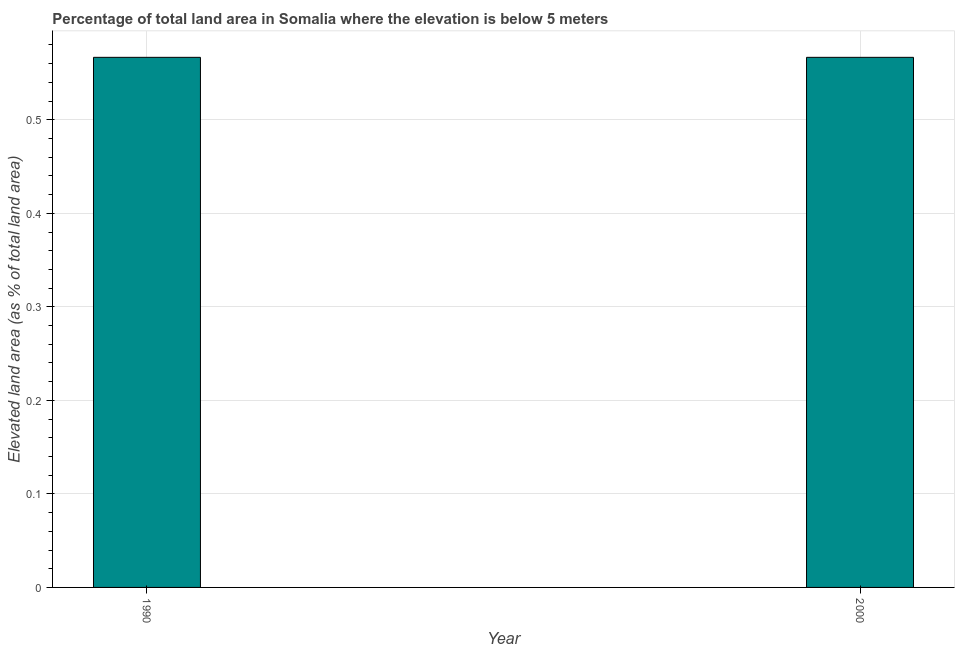Does the graph contain any zero values?
Make the answer very short. No. Does the graph contain grids?
Your answer should be very brief. Yes. What is the title of the graph?
Your answer should be compact. Percentage of total land area in Somalia where the elevation is below 5 meters. What is the label or title of the Y-axis?
Your response must be concise. Elevated land area (as % of total land area). What is the total elevated land area in 1990?
Your answer should be very brief. 0.57. Across all years, what is the maximum total elevated land area?
Ensure brevity in your answer.  0.57. Across all years, what is the minimum total elevated land area?
Keep it short and to the point. 0.57. In which year was the total elevated land area maximum?
Your answer should be compact. 1990. What is the sum of the total elevated land area?
Provide a short and direct response. 1.13. What is the difference between the total elevated land area in 1990 and 2000?
Give a very brief answer. 0. What is the average total elevated land area per year?
Provide a short and direct response. 0.57. What is the median total elevated land area?
Offer a very short reply. 0.57. Do a majority of the years between 1990 and 2000 (inclusive) have total elevated land area greater than 0.16 %?
Keep it short and to the point. Yes. What is the ratio of the total elevated land area in 1990 to that in 2000?
Keep it short and to the point. 1. In how many years, is the total elevated land area greater than the average total elevated land area taken over all years?
Offer a very short reply. 0. How many bars are there?
Your answer should be very brief. 2. How many years are there in the graph?
Provide a short and direct response. 2. What is the Elevated land area (as % of total land area) of 1990?
Offer a terse response. 0.57. What is the Elevated land area (as % of total land area) of 2000?
Provide a short and direct response. 0.57. What is the difference between the Elevated land area (as % of total land area) in 1990 and 2000?
Keep it short and to the point. 0. What is the ratio of the Elevated land area (as % of total land area) in 1990 to that in 2000?
Ensure brevity in your answer.  1. 